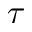Convert formula to latex. <formula><loc_0><loc_0><loc_500><loc_500>\tau</formula> 